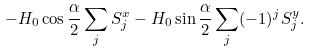Convert formula to latex. <formula><loc_0><loc_0><loc_500><loc_500>- H _ { 0 } \cos { \frac { \alpha } { 2 } } \sum _ { j } S ^ { x } _ { j } - H _ { 0 } \sin { \frac { \alpha } { 2 } } \sum _ { j } ( - 1 ) ^ { j } S ^ { y } _ { j } .</formula> 